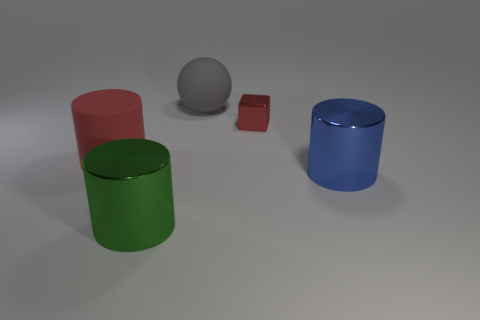Is there anything else that has the same size as the red cube?
Make the answer very short. No. Is the number of big balls on the left side of the gray object the same as the number of yellow blocks?
Your answer should be very brief. Yes. There is a cylinder that is in front of the large metallic object that is behind the metal cylinder to the left of the blue cylinder; what is its material?
Your answer should be compact. Metal. What shape is the blue object that is made of the same material as the tiny red block?
Ensure brevity in your answer.  Cylinder. Are there any other things that are the same color as the tiny thing?
Offer a very short reply. Yes. There is a metal object behind the big cylinder that is on the left side of the big green cylinder; what number of green cylinders are to the right of it?
Your answer should be compact. 0. What number of gray objects are either tiny metallic cubes or matte things?
Provide a short and direct response. 1. There is a blue metal cylinder; is it the same size as the matte object behind the red metallic object?
Your answer should be compact. Yes. What is the material of the green object that is the same shape as the blue thing?
Provide a short and direct response. Metal. What number of other things are the same size as the blue metal object?
Ensure brevity in your answer.  3. 